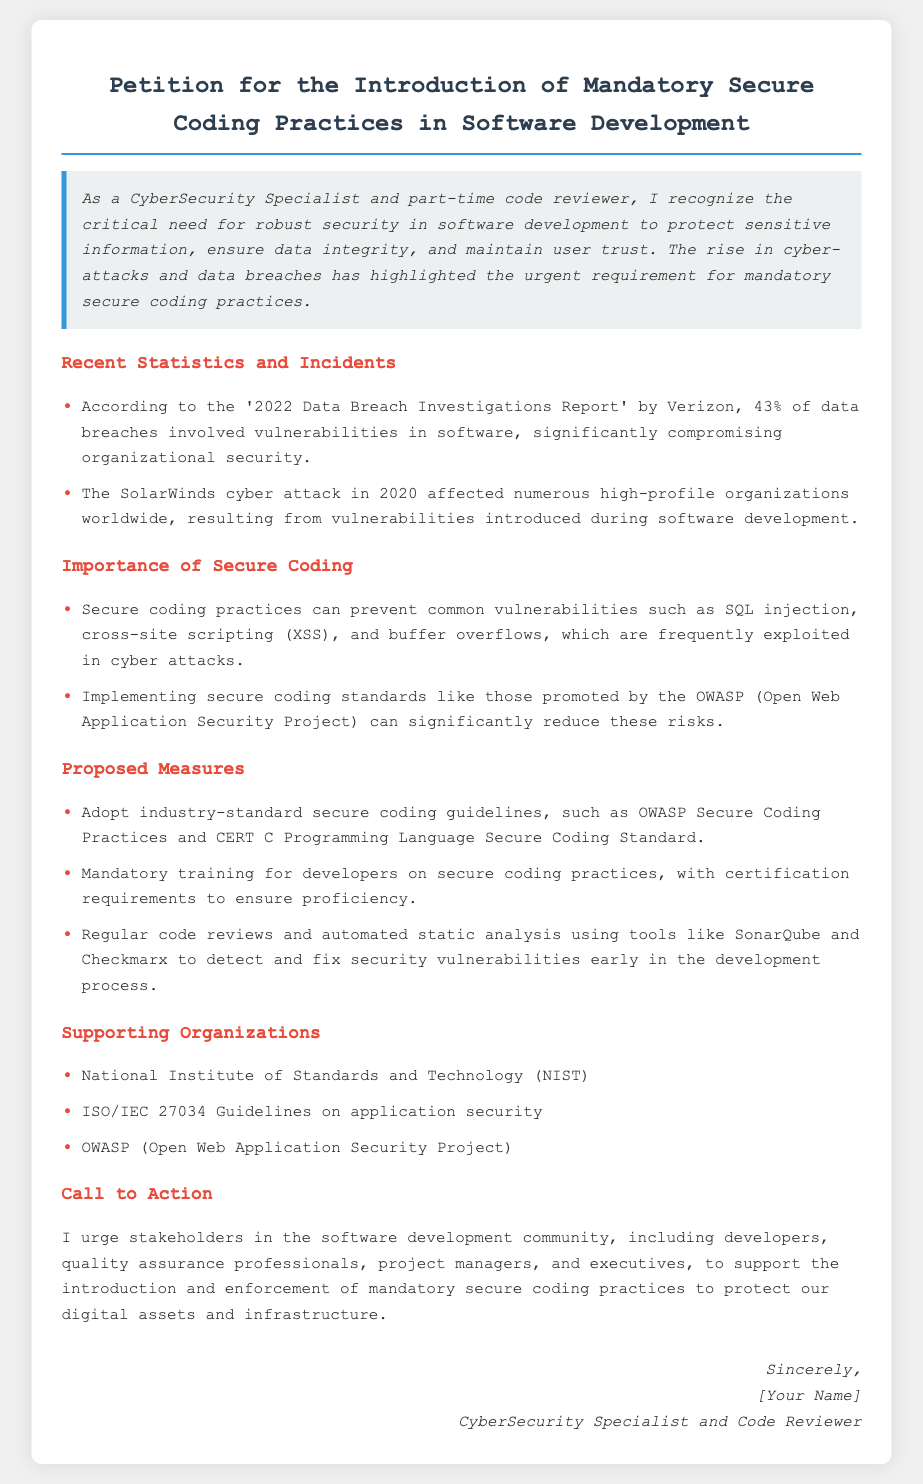What is the title of the petition? The title of the petition is stated at the top of the document.
Answer: Petition for the Introduction of Mandatory Secure Coding Practices in Software Development What organization conducted the '2022 Data Breach Investigations Report'? The document references a specific report and its author in the statistics section.
Answer: Verizon What percentage of data breaches involved vulnerabilities in software? This percentage is directly mentioned in the document under Recent Statistics and Incidents.
Answer: 43% Which major cyber attack is mentioned in the petition? The document discusses a specific incident as an example in the statistics section.
Answer: SolarWinds What guideline is recommended for secure coding practices? The document lists specific secure coding guidelines in the Proposed Measures section.
Answer: OWASP Secure Coding Practices What is one proposed measure for enhancing secure coding practices? The document suggests several methods to improve secure coding in the Proposed Measures section.
Answer: Mandatory training for developers Which organization supports the push for secure coding practices? The document lists supportive organizations in the Supporting Organizations section.
Answer: National Institute of Standards and Technology (NIST) What does the petition urge stakeholders in the software development community to do? The call to action provides the main request articulated in the document.
Answer: Support the introduction and enforcement of mandatory secure coding practices 